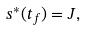Convert formula to latex. <formula><loc_0><loc_0><loc_500><loc_500>s ^ { * } ( t _ { f } ) = J ,</formula> 